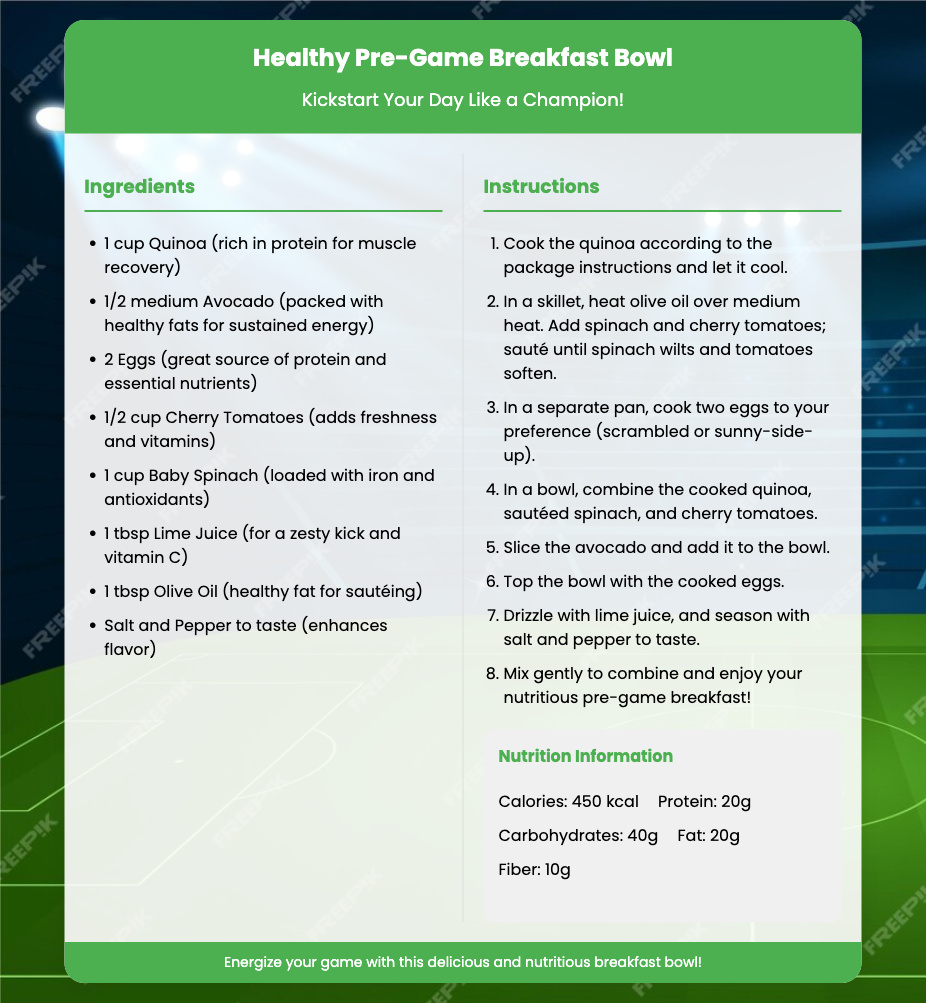What are the main ingredients? The recipe card lists the main ingredients, including quinoa, avocado, eggs, cherry tomatoes, baby spinach, lime juice, and olive oil.
Answer: Quinoa, avocado, eggs, cherry tomatoes, baby spinach, lime juice, olive oil How many eggs are used? The recipe specifies that two eggs are used in the breakfast bowl.
Answer: 2 eggs What is the cooking method for the spinach? The instructions describe sautéing the spinach in olive oil until it wilts.
Answer: Sauté What is the purpose of lime juice in this recipe? Lime juice is included for its zesty kick and as a source of vitamin C.
Answer: Zesty kick and vitamin C How many calories does the breakfast bowl contain? The nutrition section indicates that the total calories in the breakfast bowl are 450 kcal.
Answer: 450 kcal What is the total protein content? According to the nutrition information, the breakfast bowl contains 20 grams of protein.
Answer: 20g How is the avocado prepared? The instructions specify slicing the avocado before adding it to the bowl.
Answer: Sliced What type of document is this? The document is a recipe card specifically designed for a meal preparation.
Answer: Recipe card 